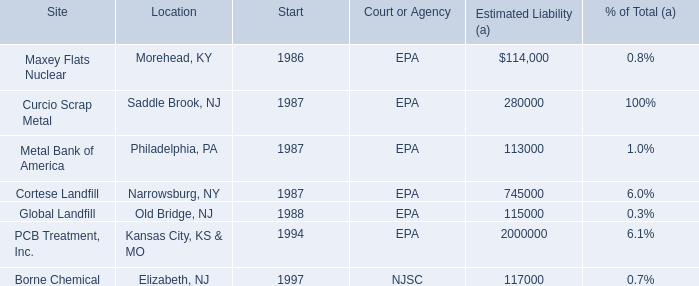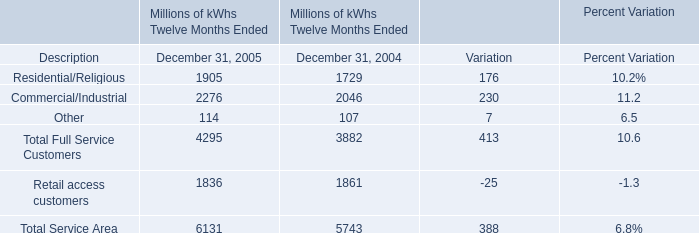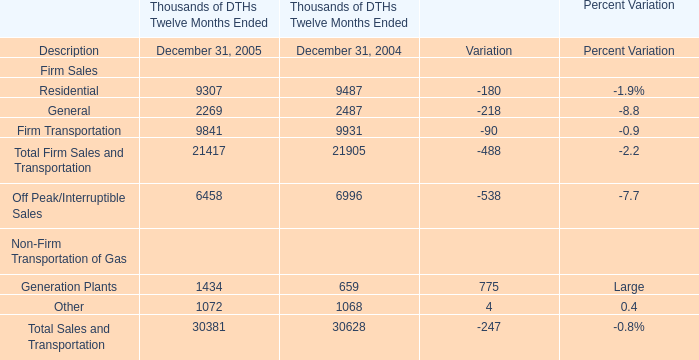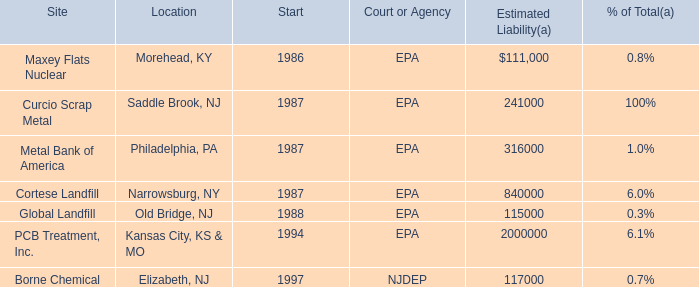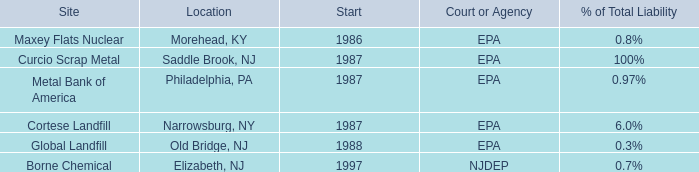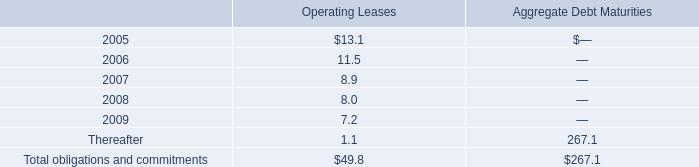What is the ratio of Other to the total in 2005? 
Computations: (114 / 6131)
Answer: 0.01859. 